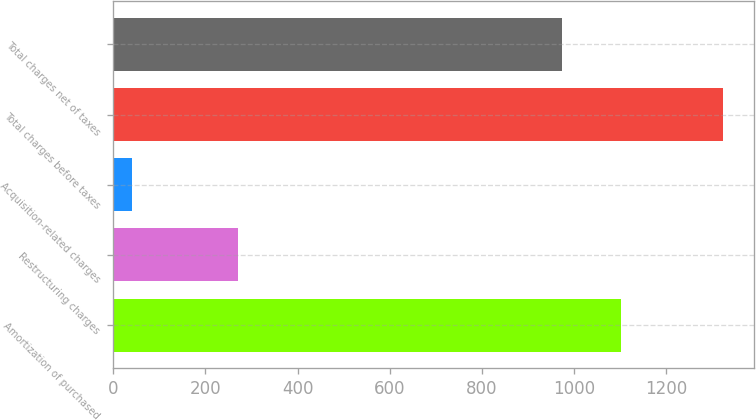Convert chart. <chart><loc_0><loc_0><loc_500><loc_500><bar_chart><fcel>Amortization of purchased<fcel>Restructuring charges<fcel>Acquisition-related charges<fcel>Total charges before taxes<fcel>Total charges net of taxes<nl><fcel>1101.2<fcel>270<fcel>41<fcel>1323<fcel>973<nl></chart> 